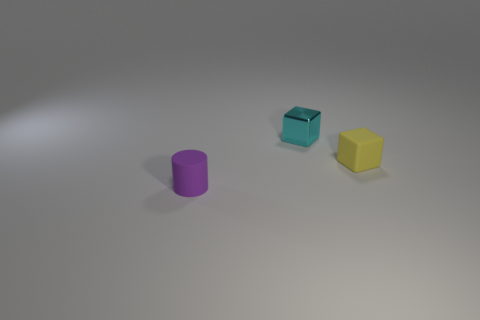Add 3 cyan metallic things. How many objects exist? 6 Subtract all blocks. How many objects are left? 1 Add 3 brown things. How many brown things exist? 3 Subtract 0 yellow cylinders. How many objects are left? 3 Subtract all small shiny cubes. Subtract all small yellow objects. How many objects are left? 1 Add 1 matte cubes. How many matte cubes are left? 2 